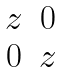Convert formula to latex. <formula><loc_0><loc_0><loc_500><loc_500>\begin{matrix} z & 0 \\ 0 & z \end{matrix}</formula> 